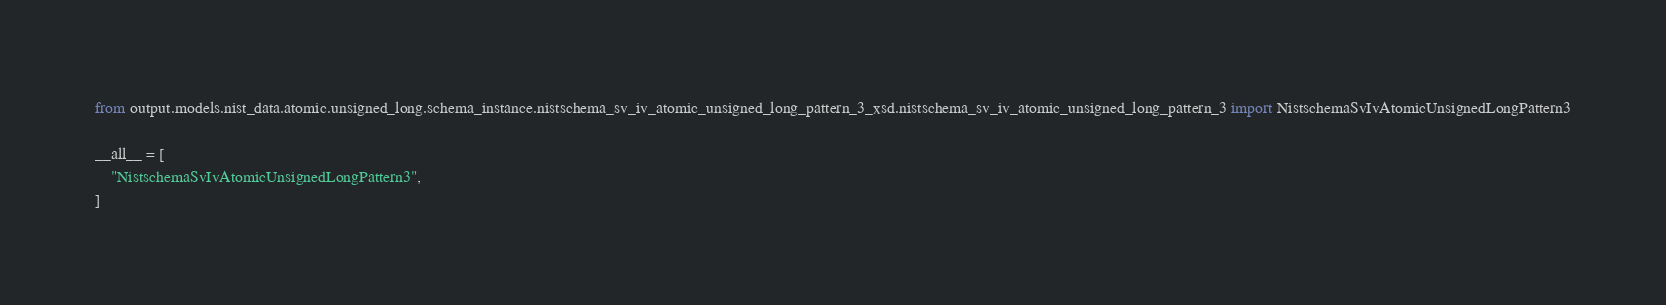Convert code to text. <code><loc_0><loc_0><loc_500><loc_500><_Python_>from output.models.nist_data.atomic.unsigned_long.schema_instance.nistschema_sv_iv_atomic_unsigned_long_pattern_3_xsd.nistschema_sv_iv_atomic_unsigned_long_pattern_3 import NistschemaSvIvAtomicUnsignedLongPattern3

__all__ = [
    "NistschemaSvIvAtomicUnsignedLongPattern3",
]
</code> 